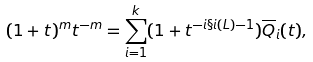Convert formula to latex. <formula><loc_0><loc_0><loc_500><loc_500>( 1 + t ) ^ { m } t ^ { - m } = \sum _ { i = 1 } ^ { k } ( 1 + t ^ { - i \S i ( L ) - 1 } ) \overline { Q } _ { i } ( t ) ,</formula> 